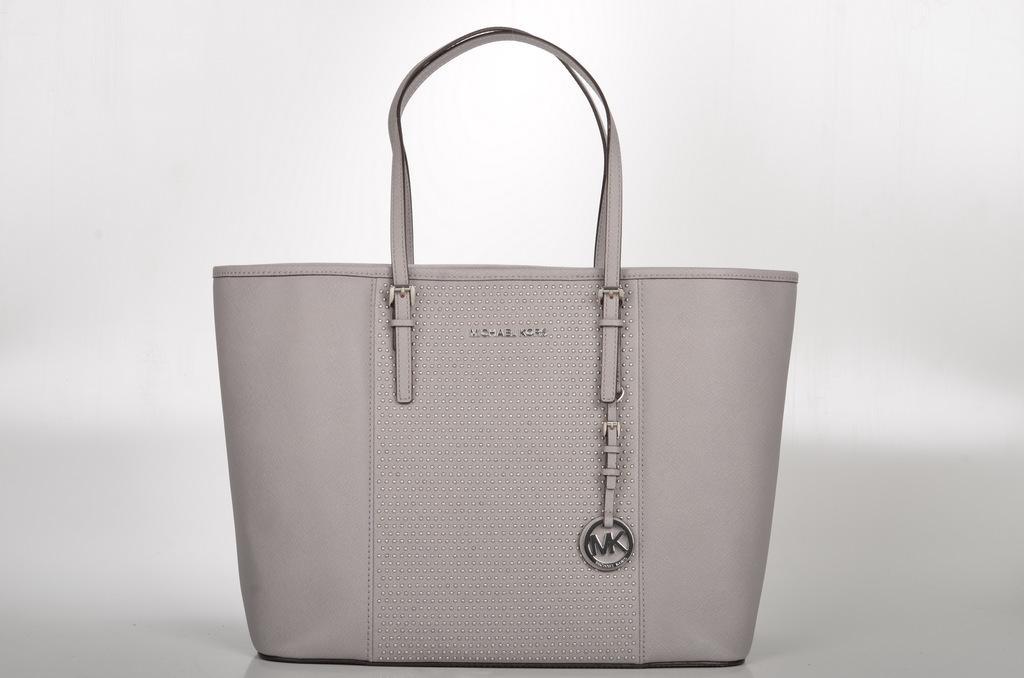Describe this image in one or two sentences. In this image, a handbag is there of ash in color which is kept on the floor. This image is taken inside a room. 